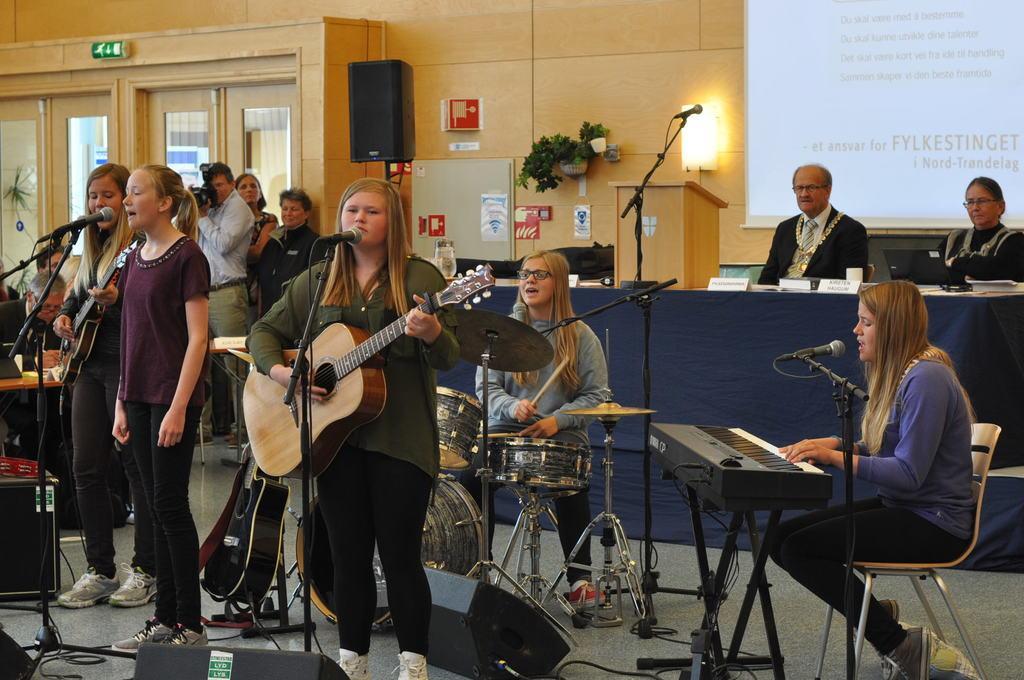Please provide a concise description of this image. A screen, light and plant is on wall. Far there is a speaker with stand. These persons are sitting on a chair, in-front of this person there is a table, on this table there is a laptop. Front this group of people are playing this musical instruments and singing in-front of mic. 